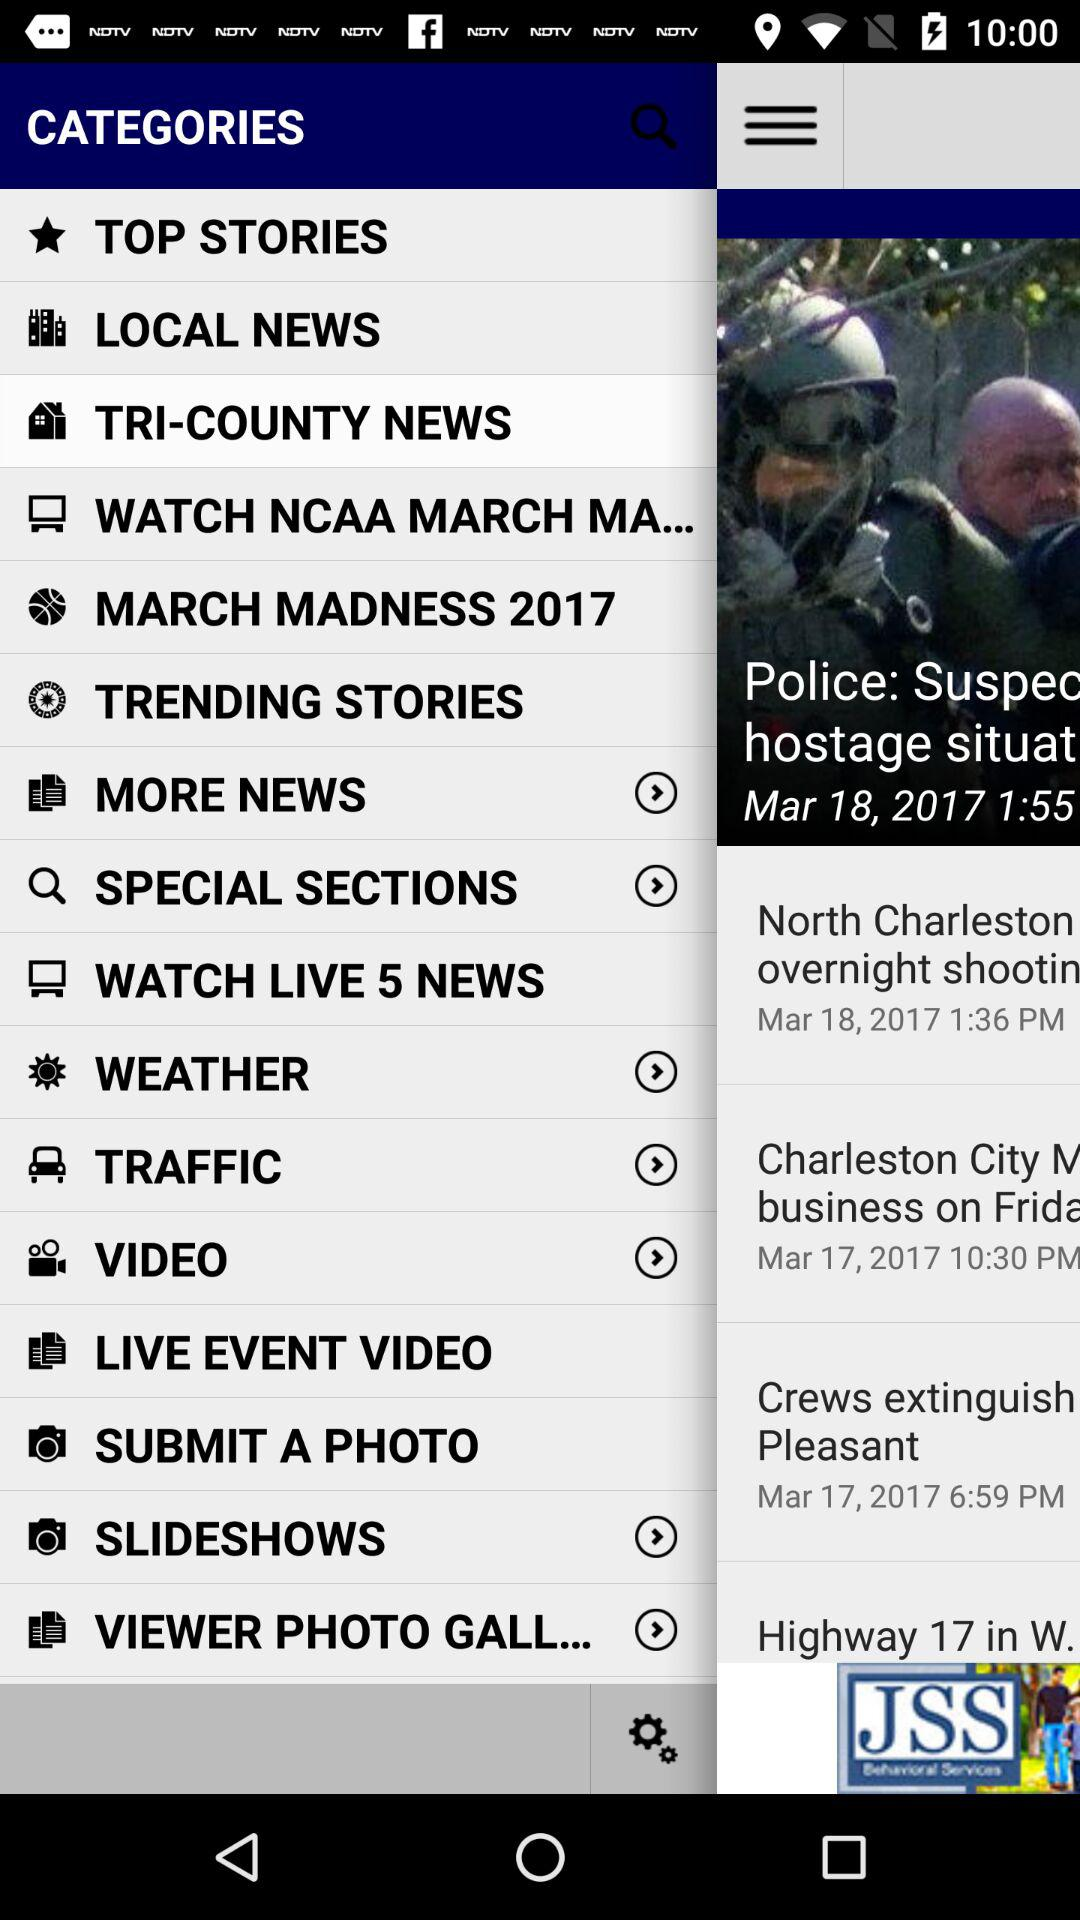Which item is selected in the menu? The selected item is "TRI-COUNTY NEWS". 